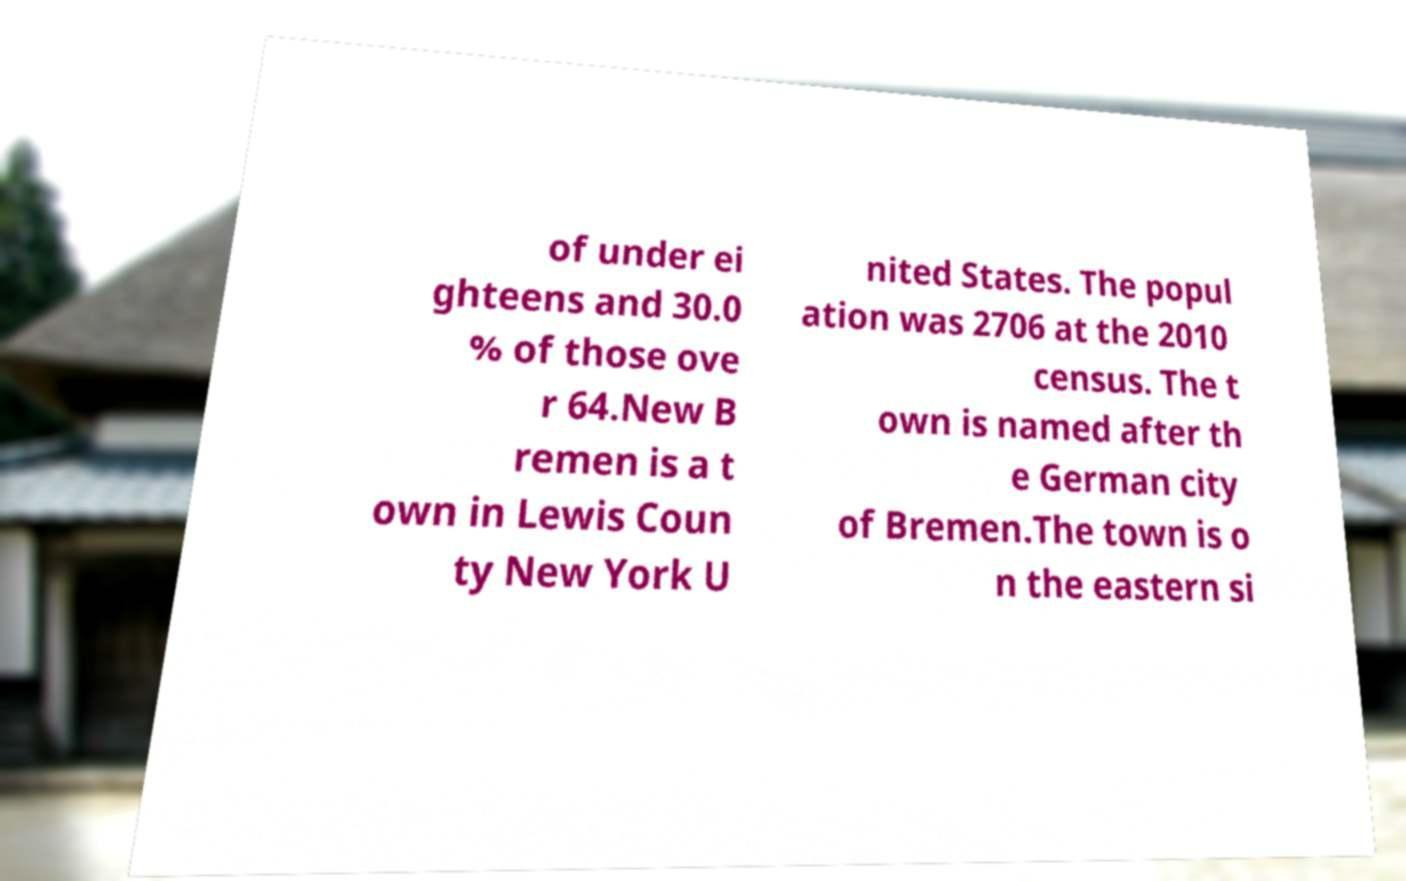Could you assist in decoding the text presented in this image and type it out clearly? of under ei ghteens and 30.0 % of those ove r 64.New B remen is a t own in Lewis Coun ty New York U nited States. The popul ation was 2706 at the 2010 census. The t own is named after th e German city of Bremen.The town is o n the eastern si 